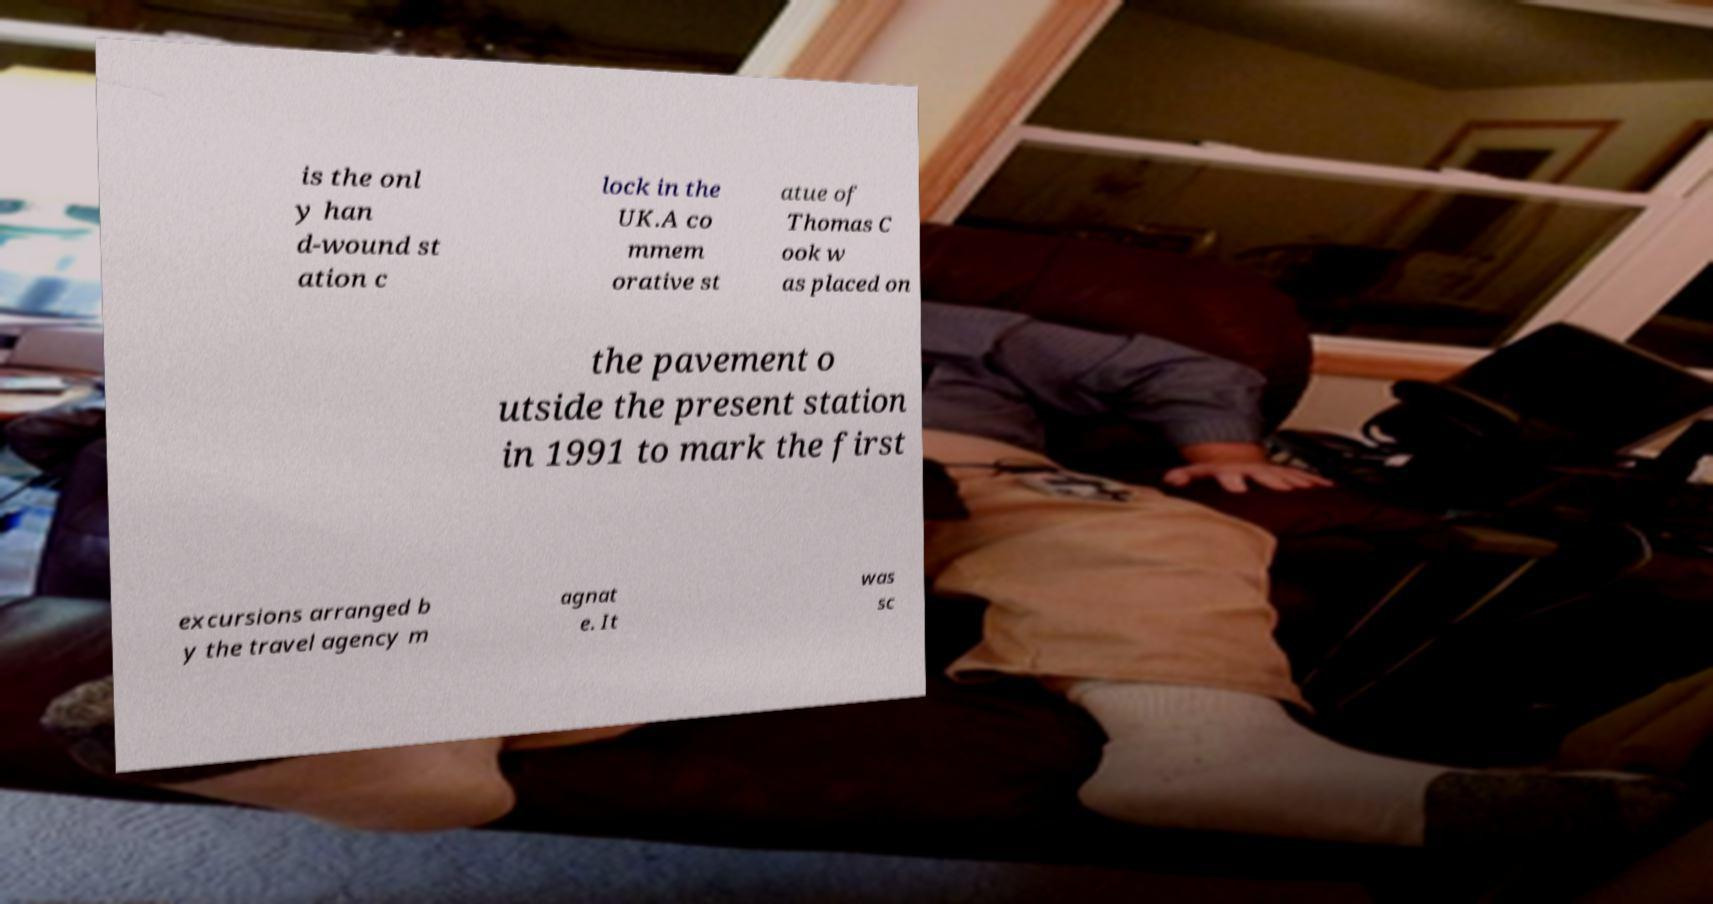Can you accurately transcribe the text from the provided image for me? is the onl y han d-wound st ation c lock in the UK.A co mmem orative st atue of Thomas C ook w as placed on the pavement o utside the present station in 1991 to mark the first excursions arranged b y the travel agency m agnat e. It was sc 